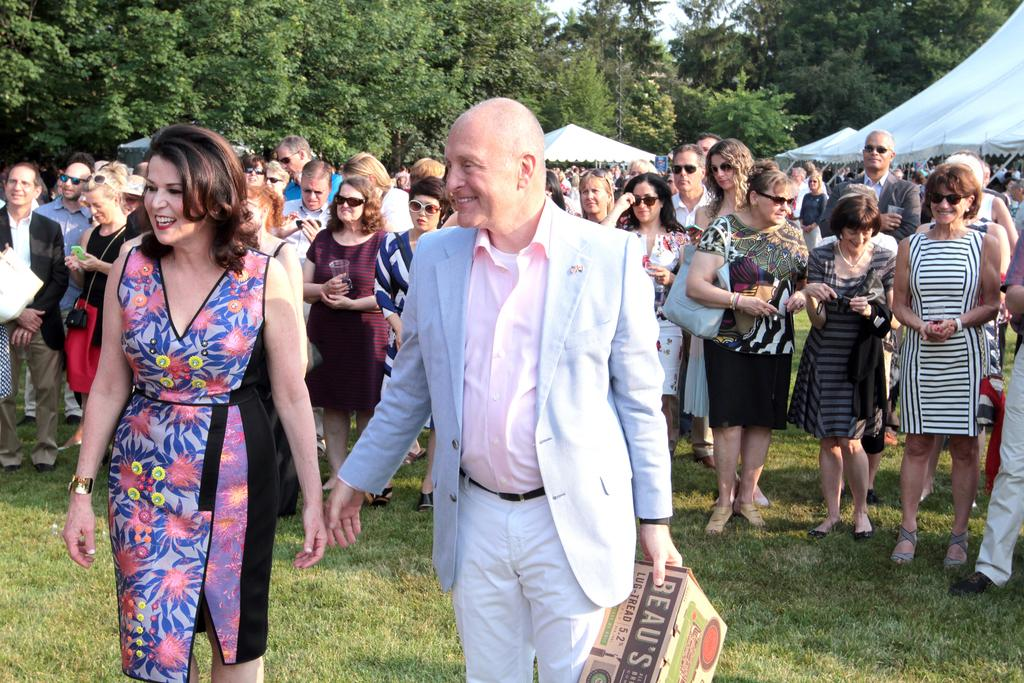How many people are in the image? There is a group of people in the image, but the exact number cannot be determined from the provided facts. What is the man holding in the image? The man is holding a box in the image. What type of terrain is visible in the image? There is grass visible in the image, suggesting a grassy area. What structures can be seen in the background of the image? There are tents in the background of the image. What else can be seen in the background of the image? Trees and the sky are visible in the background of the image. What type of ticket does the man's mom have in the image? There is no mention of a ticket or the man's mom in the provided facts, so it cannot be determined from the image. 